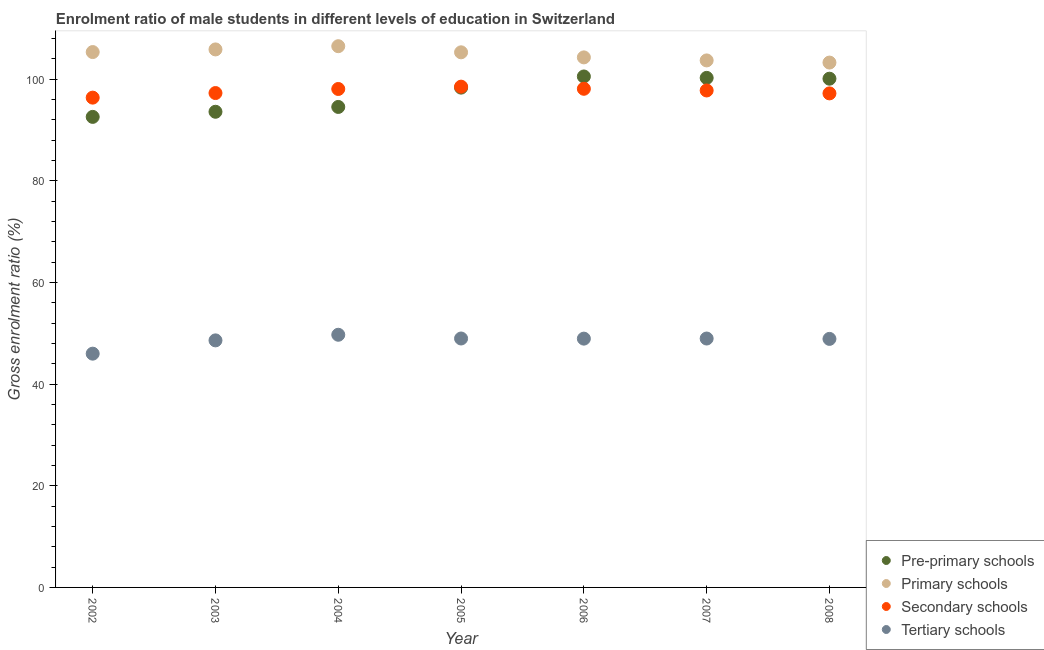How many different coloured dotlines are there?
Give a very brief answer. 4. What is the gross enrolment ratio(female) in primary schools in 2005?
Provide a short and direct response. 105.25. Across all years, what is the maximum gross enrolment ratio(female) in tertiary schools?
Your answer should be compact. 49.7. Across all years, what is the minimum gross enrolment ratio(female) in pre-primary schools?
Your response must be concise. 92.55. In which year was the gross enrolment ratio(female) in primary schools minimum?
Keep it short and to the point. 2008. What is the total gross enrolment ratio(female) in secondary schools in the graph?
Provide a short and direct response. 683.11. What is the difference between the gross enrolment ratio(female) in primary schools in 2005 and that in 2006?
Make the answer very short. 1. What is the difference between the gross enrolment ratio(female) in pre-primary schools in 2008 and the gross enrolment ratio(female) in tertiary schools in 2005?
Give a very brief answer. 51.1. What is the average gross enrolment ratio(female) in pre-primary schools per year?
Offer a very short reply. 97.1. In the year 2007, what is the difference between the gross enrolment ratio(female) in secondary schools and gross enrolment ratio(female) in pre-primary schools?
Provide a short and direct response. -2.48. In how many years, is the gross enrolment ratio(female) in pre-primary schools greater than 84 %?
Give a very brief answer. 7. What is the ratio of the gross enrolment ratio(female) in pre-primary schools in 2002 to that in 2005?
Keep it short and to the point. 0.94. Is the gross enrolment ratio(female) in secondary schools in 2004 less than that in 2005?
Your answer should be compact. Yes. Is the difference between the gross enrolment ratio(female) in primary schools in 2002 and 2005 greater than the difference between the gross enrolment ratio(female) in tertiary schools in 2002 and 2005?
Your response must be concise. Yes. What is the difference between the highest and the second highest gross enrolment ratio(female) in primary schools?
Offer a very short reply. 0.63. What is the difference between the highest and the lowest gross enrolment ratio(female) in primary schools?
Your response must be concise. 3.22. In how many years, is the gross enrolment ratio(female) in secondary schools greater than the average gross enrolment ratio(female) in secondary schools taken over all years?
Provide a succinct answer. 4. Is the sum of the gross enrolment ratio(female) in secondary schools in 2002 and 2004 greater than the maximum gross enrolment ratio(female) in tertiary schools across all years?
Ensure brevity in your answer.  Yes. Does the gross enrolment ratio(female) in tertiary schools monotonically increase over the years?
Keep it short and to the point. No. Is the gross enrolment ratio(female) in pre-primary schools strictly greater than the gross enrolment ratio(female) in tertiary schools over the years?
Your response must be concise. Yes. Is the gross enrolment ratio(female) in primary schools strictly less than the gross enrolment ratio(female) in secondary schools over the years?
Provide a succinct answer. No. How many dotlines are there?
Keep it short and to the point. 4. How many legend labels are there?
Your answer should be compact. 4. What is the title of the graph?
Provide a short and direct response. Enrolment ratio of male students in different levels of education in Switzerland. Does "Permanent crop land" appear as one of the legend labels in the graph?
Your response must be concise. No. What is the label or title of the X-axis?
Keep it short and to the point. Year. What is the Gross enrolment ratio (%) in Pre-primary schools in 2002?
Provide a succinct answer. 92.55. What is the Gross enrolment ratio (%) of Primary schools in 2002?
Offer a very short reply. 105.3. What is the Gross enrolment ratio (%) of Secondary schools in 2002?
Provide a succinct answer. 96.34. What is the Gross enrolment ratio (%) in Tertiary schools in 2002?
Provide a short and direct response. 45.98. What is the Gross enrolment ratio (%) of Pre-primary schools in 2003?
Keep it short and to the point. 93.56. What is the Gross enrolment ratio (%) in Primary schools in 2003?
Give a very brief answer. 105.82. What is the Gross enrolment ratio (%) of Secondary schools in 2003?
Provide a succinct answer. 97.24. What is the Gross enrolment ratio (%) in Tertiary schools in 2003?
Provide a succinct answer. 48.59. What is the Gross enrolment ratio (%) of Pre-primary schools in 2004?
Ensure brevity in your answer.  94.51. What is the Gross enrolment ratio (%) of Primary schools in 2004?
Provide a succinct answer. 106.45. What is the Gross enrolment ratio (%) of Secondary schools in 2004?
Your response must be concise. 98.04. What is the Gross enrolment ratio (%) in Tertiary schools in 2004?
Offer a terse response. 49.7. What is the Gross enrolment ratio (%) of Pre-primary schools in 2005?
Your answer should be compact. 98.31. What is the Gross enrolment ratio (%) of Primary schools in 2005?
Provide a succinct answer. 105.25. What is the Gross enrolment ratio (%) in Secondary schools in 2005?
Provide a short and direct response. 98.5. What is the Gross enrolment ratio (%) of Tertiary schools in 2005?
Keep it short and to the point. 48.96. What is the Gross enrolment ratio (%) of Pre-primary schools in 2006?
Your answer should be compact. 100.5. What is the Gross enrolment ratio (%) of Primary schools in 2006?
Your response must be concise. 104.25. What is the Gross enrolment ratio (%) of Secondary schools in 2006?
Keep it short and to the point. 98.08. What is the Gross enrolment ratio (%) in Tertiary schools in 2006?
Keep it short and to the point. 48.94. What is the Gross enrolment ratio (%) in Pre-primary schools in 2007?
Give a very brief answer. 100.22. What is the Gross enrolment ratio (%) of Primary schools in 2007?
Offer a very short reply. 103.66. What is the Gross enrolment ratio (%) in Secondary schools in 2007?
Ensure brevity in your answer.  97.75. What is the Gross enrolment ratio (%) of Tertiary schools in 2007?
Make the answer very short. 48.96. What is the Gross enrolment ratio (%) of Pre-primary schools in 2008?
Your answer should be compact. 100.06. What is the Gross enrolment ratio (%) in Primary schools in 2008?
Provide a succinct answer. 103.23. What is the Gross enrolment ratio (%) of Secondary schools in 2008?
Provide a short and direct response. 97.17. What is the Gross enrolment ratio (%) of Tertiary schools in 2008?
Offer a very short reply. 48.88. Across all years, what is the maximum Gross enrolment ratio (%) in Pre-primary schools?
Provide a short and direct response. 100.5. Across all years, what is the maximum Gross enrolment ratio (%) of Primary schools?
Ensure brevity in your answer.  106.45. Across all years, what is the maximum Gross enrolment ratio (%) of Secondary schools?
Give a very brief answer. 98.5. Across all years, what is the maximum Gross enrolment ratio (%) of Tertiary schools?
Offer a terse response. 49.7. Across all years, what is the minimum Gross enrolment ratio (%) in Pre-primary schools?
Offer a very short reply. 92.55. Across all years, what is the minimum Gross enrolment ratio (%) in Primary schools?
Provide a succinct answer. 103.23. Across all years, what is the minimum Gross enrolment ratio (%) of Secondary schools?
Provide a short and direct response. 96.34. Across all years, what is the minimum Gross enrolment ratio (%) in Tertiary schools?
Make the answer very short. 45.98. What is the total Gross enrolment ratio (%) in Pre-primary schools in the graph?
Your answer should be compact. 679.71. What is the total Gross enrolment ratio (%) in Primary schools in the graph?
Give a very brief answer. 733.98. What is the total Gross enrolment ratio (%) in Secondary schools in the graph?
Offer a very short reply. 683.11. What is the total Gross enrolment ratio (%) of Tertiary schools in the graph?
Make the answer very short. 340.01. What is the difference between the Gross enrolment ratio (%) in Pre-primary schools in 2002 and that in 2003?
Give a very brief answer. -1.01. What is the difference between the Gross enrolment ratio (%) of Primary schools in 2002 and that in 2003?
Your answer should be very brief. -0.52. What is the difference between the Gross enrolment ratio (%) of Secondary schools in 2002 and that in 2003?
Your response must be concise. -0.9. What is the difference between the Gross enrolment ratio (%) in Tertiary schools in 2002 and that in 2003?
Provide a succinct answer. -2.61. What is the difference between the Gross enrolment ratio (%) of Pre-primary schools in 2002 and that in 2004?
Ensure brevity in your answer.  -1.96. What is the difference between the Gross enrolment ratio (%) in Primary schools in 2002 and that in 2004?
Give a very brief answer. -1.15. What is the difference between the Gross enrolment ratio (%) of Secondary schools in 2002 and that in 2004?
Your response must be concise. -1.7. What is the difference between the Gross enrolment ratio (%) of Tertiary schools in 2002 and that in 2004?
Keep it short and to the point. -3.72. What is the difference between the Gross enrolment ratio (%) in Pre-primary schools in 2002 and that in 2005?
Offer a terse response. -5.76. What is the difference between the Gross enrolment ratio (%) in Primary schools in 2002 and that in 2005?
Your response must be concise. 0.05. What is the difference between the Gross enrolment ratio (%) in Secondary schools in 2002 and that in 2005?
Keep it short and to the point. -2.16. What is the difference between the Gross enrolment ratio (%) in Tertiary schools in 2002 and that in 2005?
Your response must be concise. -2.98. What is the difference between the Gross enrolment ratio (%) in Pre-primary schools in 2002 and that in 2006?
Give a very brief answer. -7.95. What is the difference between the Gross enrolment ratio (%) in Primary schools in 2002 and that in 2006?
Your response must be concise. 1.05. What is the difference between the Gross enrolment ratio (%) in Secondary schools in 2002 and that in 2006?
Your answer should be compact. -1.74. What is the difference between the Gross enrolment ratio (%) of Tertiary schools in 2002 and that in 2006?
Provide a short and direct response. -2.96. What is the difference between the Gross enrolment ratio (%) of Pre-primary schools in 2002 and that in 2007?
Make the answer very short. -7.67. What is the difference between the Gross enrolment ratio (%) of Primary schools in 2002 and that in 2007?
Provide a short and direct response. 1.64. What is the difference between the Gross enrolment ratio (%) in Secondary schools in 2002 and that in 2007?
Your response must be concise. -1.41. What is the difference between the Gross enrolment ratio (%) in Tertiary schools in 2002 and that in 2007?
Ensure brevity in your answer.  -2.98. What is the difference between the Gross enrolment ratio (%) in Pre-primary schools in 2002 and that in 2008?
Your answer should be compact. -7.51. What is the difference between the Gross enrolment ratio (%) of Primary schools in 2002 and that in 2008?
Keep it short and to the point. 2.07. What is the difference between the Gross enrolment ratio (%) in Secondary schools in 2002 and that in 2008?
Make the answer very short. -0.84. What is the difference between the Gross enrolment ratio (%) in Tertiary schools in 2002 and that in 2008?
Your answer should be compact. -2.91. What is the difference between the Gross enrolment ratio (%) in Pre-primary schools in 2003 and that in 2004?
Your answer should be compact. -0.95. What is the difference between the Gross enrolment ratio (%) of Primary schools in 2003 and that in 2004?
Offer a terse response. -0.63. What is the difference between the Gross enrolment ratio (%) in Secondary schools in 2003 and that in 2004?
Offer a terse response. -0.8. What is the difference between the Gross enrolment ratio (%) in Tertiary schools in 2003 and that in 2004?
Give a very brief answer. -1.1. What is the difference between the Gross enrolment ratio (%) in Pre-primary schools in 2003 and that in 2005?
Your response must be concise. -4.75. What is the difference between the Gross enrolment ratio (%) of Primary schools in 2003 and that in 2005?
Your response must be concise. 0.57. What is the difference between the Gross enrolment ratio (%) in Secondary schools in 2003 and that in 2005?
Your response must be concise. -1.26. What is the difference between the Gross enrolment ratio (%) of Tertiary schools in 2003 and that in 2005?
Keep it short and to the point. -0.37. What is the difference between the Gross enrolment ratio (%) of Pre-primary schools in 2003 and that in 2006?
Provide a short and direct response. -6.94. What is the difference between the Gross enrolment ratio (%) in Primary schools in 2003 and that in 2006?
Keep it short and to the point. 1.57. What is the difference between the Gross enrolment ratio (%) in Secondary schools in 2003 and that in 2006?
Keep it short and to the point. -0.84. What is the difference between the Gross enrolment ratio (%) in Tertiary schools in 2003 and that in 2006?
Your answer should be very brief. -0.34. What is the difference between the Gross enrolment ratio (%) of Pre-primary schools in 2003 and that in 2007?
Keep it short and to the point. -6.67. What is the difference between the Gross enrolment ratio (%) in Primary schools in 2003 and that in 2007?
Your answer should be very brief. 2.16. What is the difference between the Gross enrolment ratio (%) of Secondary schools in 2003 and that in 2007?
Provide a short and direct response. -0.51. What is the difference between the Gross enrolment ratio (%) of Tertiary schools in 2003 and that in 2007?
Keep it short and to the point. -0.36. What is the difference between the Gross enrolment ratio (%) of Pre-primary schools in 2003 and that in 2008?
Offer a terse response. -6.5. What is the difference between the Gross enrolment ratio (%) of Primary schools in 2003 and that in 2008?
Offer a very short reply. 2.59. What is the difference between the Gross enrolment ratio (%) of Secondary schools in 2003 and that in 2008?
Your answer should be compact. 0.07. What is the difference between the Gross enrolment ratio (%) in Tertiary schools in 2003 and that in 2008?
Your response must be concise. -0.29. What is the difference between the Gross enrolment ratio (%) in Pre-primary schools in 2004 and that in 2005?
Offer a very short reply. -3.8. What is the difference between the Gross enrolment ratio (%) of Primary schools in 2004 and that in 2005?
Provide a short and direct response. 1.2. What is the difference between the Gross enrolment ratio (%) of Secondary schools in 2004 and that in 2005?
Your response must be concise. -0.46. What is the difference between the Gross enrolment ratio (%) of Tertiary schools in 2004 and that in 2005?
Offer a terse response. 0.73. What is the difference between the Gross enrolment ratio (%) of Pre-primary schools in 2004 and that in 2006?
Your response must be concise. -5.99. What is the difference between the Gross enrolment ratio (%) of Primary schools in 2004 and that in 2006?
Make the answer very short. 2.2. What is the difference between the Gross enrolment ratio (%) of Secondary schools in 2004 and that in 2006?
Provide a succinct answer. -0.04. What is the difference between the Gross enrolment ratio (%) in Tertiary schools in 2004 and that in 2006?
Offer a very short reply. 0.76. What is the difference between the Gross enrolment ratio (%) in Pre-primary schools in 2004 and that in 2007?
Ensure brevity in your answer.  -5.72. What is the difference between the Gross enrolment ratio (%) in Primary schools in 2004 and that in 2007?
Provide a succinct answer. 2.8. What is the difference between the Gross enrolment ratio (%) of Secondary schools in 2004 and that in 2007?
Provide a succinct answer. 0.29. What is the difference between the Gross enrolment ratio (%) of Tertiary schools in 2004 and that in 2007?
Make the answer very short. 0.74. What is the difference between the Gross enrolment ratio (%) in Pre-primary schools in 2004 and that in 2008?
Your response must be concise. -5.56. What is the difference between the Gross enrolment ratio (%) in Primary schools in 2004 and that in 2008?
Keep it short and to the point. 3.22. What is the difference between the Gross enrolment ratio (%) in Secondary schools in 2004 and that in 2008?
Your answer should be compact. 0.87. What is the difference between the Gross enrolment ratio (%) in Tertiary schools in 2004 and that in 2008?
Make the answer very short. 0.81. What is the difference between the Gross enrolment ratio (%) in Pre-primary schools in 2005 and that in 2006?
Provide a short and direct response. -2.19. What is the difference between the Gross enrolment ratio (%) of Secondary schools in 2005 and that in 2006?
Keep it short and to the point. 0.42. What is the difference between the Gross enrolment ratio (%) of Tertiary schools in 2005 and that in 2006?
Your response must be concise. 0.03. What is the difference between the Gross enrolment ratio (%) of Pre-primary schools in 2005 and that in 2007?
Your response must be concise. -1.92. What is the difference between the Gross enrolment ratio (%) in Primary schools in 2005 and that in 2007?
Your answer should be compact. 1.59. What is the difference between the Gross enrolment ratio (%) of Secondary schools in 2005 and that in 2007?
Your answer should be very brief. 0.75. What is the difference between the Gross enrolment ratio (%) of Tertiary schools in 2005 and that in 2007?
Give a very brief answer. 0.01. What is the difference between the Gross enrolment ratio (%) in Pre-primary schools in 2005 and that in 2008?
Ensure brevity in your answer.  -1.76. What is the difference between the Gross enrolment ratio (%) in Primary schools in 2005 and that in 2008?
Keep it short and to the point. 2.02. What is the difference between the Gross enrolment ratio (%) in Secondary schools in 2005 and that in 2008?
Your answer should be compact. 1.33. What is the difference between the Gross enrolment ratio (%) of Tertiary schools in 2005 and that in 2008?
Offer a terse response. 0.08. What is the difference between the Gross enrolment ratio (%) in Pre-primary schools in 2006 and that in 2007?
Provide a succinct answer. 0.28. What is the difference between the Gross enrolment ratio (%) in Primary schools in 2006 and that in 2007?
Keep it short and to the point. 0.6. What is the difference between the Gross enrolment ratio (%) of Secondary schools in 2006 and that in 2007?
Provide a succinct answer. 0.33. What is the difference between the Gross enrolment ratio (%) in Tertiary schools in 2006 and that in 2007?
Make the answer very short. -0.02. What is the difference between the Gross enrolment ratio (%) of Pre-primary schools in 2006 and that in 2008?
Your answer should be compact. 0.44. What is the difference between the Gross enrolment ratio (%) of Primary schools in 2006 and that in 2008?
Offer a terse response. 1.02. What is the difference between the Gross enrolment ratio (%) in Secondary schools in 2006 and that in 2008?
Provide a succinct answer. 0.91. What is the difference between the Gross enrolment ratio (%) of Tertiary schools in 2006 and that in 2008?
Ensure brevity in your answer.  0.05. What is the difference between the Gross enrolment ratio (%) of Pre-primary schools in 2007 and that in 2008?
Keep it short and to the point. 0.16. What is the difference between the Gross enrolment ratio (%) in Primary schools in 2007 and that in 2008?
Offer a terse response. 0.42. What is the difference between the Gross enrolment ratio (%) of Secondary schools in 2007 and that in 2008?
Make the answer very short. 0.57. What is the difference between the Gross enrolment ratio (%) of Tertiary schools in 2007 and that in 2008?
Your response must be concise. 0.07. What is the difference between the Gross enrolment ratio (%) in Pre-primary schools in 2002 and the Gross enrolment ratio (%) in Primary schools in 2003?
Your answer should be very brief. -13.27. What is the difference between the Gross enrolment ratio (%) of Pre-primary schools in 2002 and the Gross enrolment ratio (%) of Secondary schools in 2003?
Your answer should be compact. -4.69. What is the difference between the Gross enrolment ratio (%) in Pre-primary schools in 2002 and the Gross enrolment ratio (%) in Tertiary schools in 2003?
Provide a succinct answer. 43.96. What is the difference between the Gross enrolment ratio (%) of Primary schools in 2002 and the Gross enrolment ratio (%) of Secondary schools in 2003?
Offer a terse response. 8.06. What is the difference between the Gross enrolment ratio (%) in Primary schools in 2002 and the Gross enrolment ratio (%) in Tertiary schools in 2003?
Provide a short and direct response. 56.71. What is the difference between the Gross enrolment ratio (%) in Secondary schools in 2002 and the Gross enrolment ratio (%) in Tertiary schools in 2003?
Give a very brief answer. 47.74. What is the difference between the Gross enrolment ratio (%) of Pre-primary schools in 2002 and the Gross enrolment ratio (%) of Primary schools in 2004?
Ensure brevity in your answer.  -13.9. What is the difference between the Gross enrolment ratio (%) in Pre-primary schools in 2002 and the Gross enrolment ratio (%) in Secondary schools in 2004?
Provide a succinct answer. -5.49. What is the difference between the Gross enrolment ratio (%) of Pre-primary schools in 2002 and the Gross enrolment ratio (%) of Tertiary schools in 2004?
Ensure brevity in your answer.  42.85. What is the difference between the Gross enrolment ratio (%) in Primary schools in 2002 and the Gross enrolment ratio (%) in Secondary schools in 2004?
Your response must be concise. 7.26. What is the difference between the Gross enrolment ratio (%) of Primary schools in 2002 and the Gross enrolment ratio (%) of Tertiary schools in 2004?
Your answer should be very brief. 55.6. What is the difference between the Gross enrolment ratio (%) in Secondary schools in 2002 and the Gross enrolment ratio (%) in Tertiary schools in 2004?
Ensure brevity in your answer.  46.64. What is the difference between the Gross enrolment ratio (%) in Pre-primary schools in 2002 and the Gross enrolment ratio (%) in Primary schools in 2005?
Provide a short and direct response. -12.7. What is the difference between the Gross enrolment ratio (%) of Pre-primary schools in 2002 and the Gross enrolment ratio (%) of Secondary schools in 2005?
Keep it short and to the point. -5.95. What is the difference between the Gross enrolment ratio (%) in Pre-primary schools in 2002 and the Gross enrolment ratio (%) in Tertiary schools in 2005?
Ensure brevity in your answer.  43.59. What is the difference between the Gross enrolment ratio (%) of Primary schools in 2002 and the Gross enrolment ratio (%) of Secondary schools in 2005?
Your answer should be compact. 6.8. What is the difference between the Gross enrolment ratio (%) of Primary schools in 2002 and the Gross enrolment ratio (%) of Tertiary schools in 2005?
Your answer should be very brief. 56.34. What is the difference between the Gross enrolment ratio (%) of Secondary schools in 2002 and the Gross enrolment ratio (%) of Tertiary schools in 2005?
Make the answer very short. 47.37. What is the difference between the Gross enrolment ratio (%) in Pre-primary schools in 2002 and the Gross enrolment ratio (%) in Primary schools in 2006?
Offer a very short reply. -11.7. What is the difference between the Gross enrolment ratio (%) of Pre-primary schools in 2002 and the Gross enrolment ratio (%) of Secondary schools in 2006?
Provide a short and direct response. -5.53. What is the difference between the Gross enrolment ratio (%) in Pre-primary schools in 2002 and the Gross enrolment ratio (%) in Tertiary schools in 2006?
Ensure brevity in your answer.  43.62. What is the difference between the Gross enrolment ratio (%) in Primary schools in 2002 and the Gross enrolment ratio (%) in Secondary schools in 2006?
Provide a short and direct response. 7.22. What is the difference between the Gross enrolment ratio (%) in Primary schools in 2002 and the Gross enrolment ratio (%) in Tertiary schools in 2006?
Give a very brief answer. 56.37. What is the difference between the Gross enrolment ratio (%) of Secondary schools in 2002 and the Gross enrolment ratio (%) of Tertiary schools in 2006?
Make the answer very short. 47.4. What is the difference between the Gross enrolment ratio (%) in Pre-primary schools in 2002 and the Gross enrolment ratio (%) in Primary schools in 2007?
Your answer should be compact. -11.11. What is the difference between the Gross enrolment ratio (%) in Pre-primary schools in 2002 and the Gross enrolment ratio (%) in Secondary schools in 2007?
Make the answer very short. -5.2. What is the difference between the Gross enrolment ratio (%) of Pre-primary schools in 2002 and the Gross enrolment ratio (%) of Tertiary schools in 2007?
Your answer should be compact. 43.59. What is the difference between the Gross enrolment ratio (%) of Primary schools in 2002 and the Gross enrolment ratio (%) of Secondary schools in 2007?
Offer a very short reply. 7.56. What is the difference between the Gross enrolment ratio (%) of Primary schools in 2002 and the Gross enrolment ratio (%) of Tertiary schools in 2007?
Keep it short and to the point. 56.35. What is the difference between the Gross enrolment ratio (%) in Secondary schools in 2002 and the Gross enrolment ratio (%) in Tertiary schools in 2007?
Offer a very short reply. 47.38. What is the difference between the Gross enrolment ratio (%) of Pre-primary schools in 2002 and the Gross enrolment ratio (%) of Primary schools in 2008?
Offer a very short reply. -10.68. What is the difference between the Gross enrolment ratio (%) in Pre-primary schools in 2002 and the Gross enrolment ratio (%) in Secondary schools in 2008?
Make the answer very short. -4.62. What is the difference between the Gross enrolment ratio (%) in Pre-primary schools in 2002 and the Gross enrolment ratio (%) in Tertiary schools in 2008?
Keep it short and to the point. 43.67. What is the difference between the Gross enrolment ratio (%) of Primary schools in 2002 and the Gross enrolment ratio (%) of Secondary schools in 2008?
Offer a very short reply. 8.13. What is the difference between the Gross enrolment ratio (%) of Primary schools in 2002 and the Gross enrolment ratio (%) of Tertiary schools in 2008?
Your response must be concise. 56.42. What is the difference between the Gross enrolment ratio (%) in Secondary schools in 2002 and the Gross enrolment ratio (%) in Tertiary schools in 2008?
Offer a very short reply. 47.45. What is the difference between the Gross enrolment ratio (%) in Pre-primary schools in 2003 and the Gross enrolment ratio (%) in Primary schools in 2004?
Provide a succinct answer. -12.9. What is the difference between the Gross enrolment ratio (%) of Pre-primary schools in 2003 and the Gross enrolment ratio (%) of Secondary schools in 2004?
Provide a succinct answer. -4.48. What is the difference between the Gross enrolment ratio (%) in Pre-primary schools in 2003 and the Gross enrolment ratio (%) in Tertiary schools in 2004?
Offer a terse response. 43.86. What is the difference between the Gross enrolment ratio (%) in Primary schools in 2003 and the Gross enrolment ratio (%) in Secondary schools in 2004?
Offer a very short reply. 7.78. What is the difference between the Gross enrolment ratio (%) in Primary schools in 2003 and the Gross enrolment ratio (%) in Tertiary schools in 2004?
Make the answer very short. 56.12. What is the difference between the Gross enrolment ratio (%) in Secondary schools in 2003 and the Gross enrolment ratio (%) in Tertiary schools in 2004?
Provide a short and direct response. 47.54. What is the difference between the Gross enrolment ratio (%) of Pre-primary schools in 2003 and the Gross enrolment ratio (%) of Primary schools in 2005?
Offer a terse response. -11.69. What is the difference between the Gross enrolment ratio (%) in Pre-primary schools in 2003 and the Gross enrolment ratio (%) in Secondary schools in 2005?
Give a very brief answer. -4.94. What is the difference between the Gross enrolment ratio (%) in Pre-primary schools in 2003 and the Gross enrolment ratio (%) in Tertiary schools in 2005?
Offer a terse response. 44.6. What is the difference between the Gross enrolment ratio (%) in Primary schools in 2003 and the Gross enrolment ratio (%) in Secondary schools in 2005?
Your answer should be very brief. 7.32. What is the difference between the Gross enrolment ratio (%) of Primary schools in 2003 and the Gross enrolment ratio (%) of Tertiary schools in 2005?
Provide a succinct answer. 56.86. What is the difference between the Gross enrolment ratio (%) in Secondary schools in 2003 and the Gross enrolment ratio (%) in Tertiary schools in 2005?
Provide a succinct answer. 48.28. What is the difference between the Gross enrolment ratio (%) in Pre-primary schools in 2003 and the Gross enrolment ratio (%) in Primary schools in 2006?
Your response must be concise. -10.7. What is the difference between the Gross enrolment ratio (%) in Pre-primary schools in 2003 and the Gross enrolment ratio (%) in Secondary schools in 2006?
Provide a succinct answer. -4.52. What is the difference between the Gross enrolment ratio (%) in Pre-primary schools in 2003 and the Gross enrolment ratio (%) in Tertiary schools in 2006?
Your answer should be very brief. 44.62. What is the difference between the Gross enrolment ratio (%) in Primary schools in 2003 and the Gross enrolment ratio (%) in Secondary schools in 2006?
Provide a succinct answer. 7.74. What is the difference between the Gross enrolment ratio (%) in Primary schools in 2003 and the Gross enrolment ratio (%) in Tertiary schools in 2006?
Make the answer very short. 56.89. What is the difference between the Gross enrolment ratio (%) of Secondary schools in 2003 and the Gross enrolment ratio (%) of Tertiary schools in 2006?
Make the answer very short. 48.3. What is the difference between the Gross enrolment ratio (%) of Pre-primary schools in 2003 and the Gross enrolment ratio (%) of Primary schools in 2007?
Your answer should be very brief. -10.1. What is the difference between the Gross enrolment ratio (%) in Pre-primary schools in 2003 and the Gross enrolment ratio (%) in Secondary schools in 2007?
Provide a short and direct response. -4.19. What is the difference between the Gross enrolment ratio (%) of Pre-primary schools in 2003 and the Gross enrolment ratio (%) of Tertiary schools in 2007?
Keep it short and to the point. 44.6. What is the difference between the Gross enrolment ratio (%) of Primary schools in 2003 and the Gross enrolment ratio (%) of Secondary schools in 2007?
Ensure brevity in your answer.  8.07. What is the difference between the Gross enrolment ratio (%) in Primary schools in 2003 and the Gross enrolment ratio (%) in Tertiary schools in 2007?
Keep it short and to the point. 56.86. What is the difference between the Gross enrolment ratio (%) in Secondary schools in 2003 and the Gross enrolment ratio (%) in Tertiary schools in 2007?
Your answer should be very brief. 48.28. What is the difference between the Gross enrolment ratio (%) in Pre-primary schools in 2003 and the Gross enrolment ratio (%) in Primary schools in 2008?
Keep it short and to the point. -9.68. What is the difference between the Gross enrolment ratio (%) of Pre-primary schools in 2003 and the Gross enrolment ratio (%) of Secondary schools in 2008?
Your answer should be very brief. -3.61. What is the difference between the Gross enrolment ratio (%) in Pre-primary schools in 2003 and the Gross enrolment ratio (%) in Tertiary schools in 2008?
Make the answer very short. 44.67. What is the difference between the Gross enrolment ratio (%) in Primary schools in 2003 and the Gross enrolment ratio (%) in Secondary schools in 2008?
Give a very brief answer. 8.65. What is the difference between the Gross enrolment ratio (%) of Primary schools in 2003 and the Gross enrolment ratio (%) of Tertiary schools in 2008?
Provide a short and direct response. 56.94. What is the difference between the Gross enrolment ratio (%) of Secondary schools in 2003 and the Gross enrolment ratio (%) of Tertiary schools in 2008?
Offer a terse response. 48.36. What is the difference between the Gross enrolment ratio (%) of Pre-primary schools in 2004 and the Gross enrolment ratio (%) of Primary schools in 2005?
Ensure brevity in your answer.  -10.74. What is the difference between the Gross enrolment ratio (%) in Pre-primary schools in 2004 and the Gross enrolment ratio (%) in Secondary schools in 2005?
Your answer should be very brief. -3.99. What is the difference between the Gross enrolment ratio (%) of Pre-primary schools in 2004 and the Gross enrolment ratio (%) of Tertiary schools in 2005?
Offer a terse response. 45.55. What is the difference between the Gross enrolment ratio (%) of Primary schools in 2004 and the Gross enrolment ratio (%) of Secondary schools in 2005?
Your response must be concise. 7.96. What is the difference between the Gross enrolment ratio (%) in Primary schools in 2004 and the Gross enrolment ratio (%) in Tertiary schools in 2005?
Provide a succinct answer. 57.49. What is the difference between the Gross enrolment ratio (%) in Secondary schools in 2004 and the Gross enrolment ratio (%) in Tertiary schools in 2005?
Give a very brief answer. 49.08. What is the difference between the Gross enrolment ratio (%) of Pre-primary schools in 2004 and the Gross enrolment ratio (%) of Primary schools in 2006?
Keep it short and to the point. -9.75. What is the difference between the Gross enrolment ratio (%) of Pre-primary schools in 2004 and the Gross enrolment ratio (%) of Secondary schools in 2006?
Keep it short and to the point. -3.57. What is the difference between the Gross enrolment ratio (%) in Pre-primary schools in 2004 and the Gross enrolment ratio (%) in Tertiary schools in 2006?
Provide a short and direct response. 45.57. What is the difference between the Gross enrolment ratio (%) of Primary schools in 2004 and the Gross enrolment ratio (%) of Secondary schools in 2006?
Ensure brevity in your answer.  8.38. What is the difference between the Gross enrolment ratio (%) in Primary schools in 2004 and the Gross enrolment ratio (%) in Tertiary schools in 2006?
Your response must be concise. 57.52. What is the difference between the Gross enrolment ratio (%) in Secondary schools in 2004 and the Gross enrolment ratio (%) in Tertiary schools in 2006?
Give a very brief answer. 49.1. What is the difference between the Gross enrolment ratio (%) of Pre-primary schools in 2004 and the Gross enrolment ratio (%) of Primary schools in 2007?
Your response must be concise. -9.15. What is the difference between the Gross enrolment ratio (%) in Pre-primary schools in 2004 and the Gross enrolment ratio (%) in Secondary schools in 2007?
Your response must be concise. -3.24. What is the difference between the Gross enrolment ratio (%) of Pre-primary schools in 2004 and the Gross enrolment ratio (%) of Tertiary schools in 2007?
Offer a terse response. 45.55. What is the difference between the Gross enrolment ratio (%) in Primary schools in 2004 and the Gross enrolment ratio (%) in Secondary schools in 2007?
Provide a succinct answer. 8.71. What is the difference between the Gross enrolment ratio (%) in Primary schools in 2004 and the Gross enrolment ratio (%) in Tertiary schools in 2007?
Your answer should be compact. 57.5. What is the difference between the Gross enrolment ratio (%) of Secondary schools in 2004 and the Gross enrolment ratio (%) of Tertiary schools in 2007?
Keep it short and to the point. 49.08. What is the difference between the Gross enrolment ratio (%) in Pre-primary schools in 2004 and the Gross enrolment ratio (%) in Primary schools in 2008?
Offer a very short reply. -8.73. What is the difference between the Gross enrolment ratio (%) of Pre-primary schools in 2004 and the Gross enrolment ratio (%) of Secondary schools in 2008?
Keep it short and to the point. -2.67. What is the difference between the Gross enrolment ratio (%) in Pre-primary schools in 2004 and the Gross enrolment ratio (%) in Tertiary schools in 2008?
Make the answer very short. 45.62. What is the difference between the Gross enrolment ratio (%) of Primary schools in 2004 and the Gross enrolment ratio (%) of Secondary schools in 2008?
Your response must be concise. 9.28. What is the difference between the Gross enrolment ratio (%) of Primary schools in 2004 and the Gross enrolment ratio (%) of Tertiary schools in 2008?
Offer a terse response. 57.57. What is the difference between the Gross enrolment ratio (%) in Secondary schools in 2004 and the Gross enrolment ratio (%) in Tertiary schools in 2008?
Provide a short and direct response. 49.16. What is the difference between the Gross enrolment ratio (%) in Pre-primary schools in 2005 and the Gross enrolment ratio (%) in Primary schools in 2006?
Your response must be concise. -5.95. What is the difference between the Gross enrolment ratio (%) in Pre-primary schools in 2005 and the Gross enrolment ratio (%) in Secondary schools in 2006?
Ensure brevity in your answer.  0.23. What is the difference between the Gross enrolment ratio (%) of Pre-primary schools in 2005 and the Gross enrolment ratio (%) of Tertiary schools in 2006?
Your answer should be very brief. 49.37. What is the difference between the Gross enrolment ratio (%) of Primary schools in 2005 and the Gross enrolment ratio (%) of Secondary schools in 2006?
Provide a short and direct response. 7.17. What is the difference between the Gross enrolment ratio (%) of Primary schools in 2005 and the Gross enrolment ratio (%) of Tertiary schools in 2006?
Keep it short and to the point. 56.32. What is the difference between the Gross enrolment ratio (%) of Secondary schools in 2005 and the Gross enrolment ratio (%) of Tertiary schools in 2006?
Your answer should be very brief. 49.56. What is the difference between the Gross enrolment ratio (%) of Pre-primary schools in 2005 and the Gross enrolment ratio (%) of Primary schools in 2007?
Give a very brief answer. -5.35. What is the difference between the Gross enrolment ratio (%) of Pre-primary schools in 2005 and the Gross enrolment ratio (%) of Secondary schools in 2007?
Ensure brevity in your answer.  0.56. What is the difference between the Gross enrolment ratio (%) of Pre-primary schools in 2005 and the Gross enrolment ratio (%) of Tertiary schools in 2007?
Your answer should be compact. 49.35. What is the difference between the Gross enrolment ratio (%) in Primary schools in 2005 and the Gross enrolment ratio (%) in Secondary schools in 2007?
Offer a terse response. 7.51. What is the difference between the Gross enrolment ratio (%) in Primary schools in 2005 and the Gross enrolment ratio (%) in Tertiary schools in 2007?
Keep it short and to the point. 56.3. What is the difference between the Gross enrolment ratio (%) in Secondary schools in 2005 and the Gross enrolment ratio (%) in Tertiary schools in 2007?
Offer a very short reply. 49.54. What is the difference between the Gross enrolment ratio (%) in Pre-primary schools in 2005 and the Gross enrolment ratio (%) in Primary schools in 2008?
Provide a succinct answer. -4.93. What is the difference between the Gross enrolment ratio (%) in Pre-primary schools in 2005 and the Gross enrolment ratio (%) in Secondary schools in 2008?
Give a very brief answer. 1.13. What is the difference between the Gross enrolment ratio (%) in Pre-primary schools in 2005 and the Gross enrolment ratio (%) in Tertiary schools in 2008?
Your response must be concise. 49.42. What is the difference between the Gross enrolment ratio (%) in Primary schools in 2005 and the Gross enrolment ratio (%) in Secondary schools in 2008?
Offer a very short reply. 8.08. What is the difference between the Gross enrolment ratio (%) in Primary schools in 2005 and the Gross enrolment ratio (%) in Tertiary schools in 2008?
Give a very brief answer. 56.37. What is the difference between the Gross enrolment ratio (%) of Secondary schools in 2005 and the Gross enrolment ratio (%) of Tertiary schools in 2008?
Your response must be concise. 49.61. What is the difference between the Gross enrolment ratio (%) of Pre-primary schools in 2006 and the Gross enrolment ratio (%) of Primary schools in 2007?
Keep it short and to the point. -3.16. What is the difference between the Gross enrolment ratio (%) in Pre-primary schools in 2006 and the Gross enrolment ratio (%) in Secondary schools in 2007?
Offer a terse response. 2.75. What is the difference between the Gross enrolment ratio (%) in Pre-primary schools in 2006 and the Gross enrolment ratio (%) in Tertiary schools in 2007?
Offer a terse response. 51.54. What is the difference between the Gross enrolment ratio (%) of Primary schools in 2006 and the Gross enrolment ratio (%) of Secondary schools in 2007?
Ensure brevity in your answer.  6.51. What is the difference between the Gross enrolment ratio (%) of Primary schools in 2006 and the Gross enrolment ratio (%) of Tertiary schools in 2007?
Your answer should be compact. 55.3. What is the difference between the Gross enrolment ratio (%) of Secondary schools in 2006 and the Gross enrolment ratio (%) of Tertiary schools in 2007?
Offer a very short reply. 49.12. What is the difference between the Gross enrolment ratio (%) of Pre-primary schools in 2006 and the Gross enrolment ratio (%) of Primary schools in 2008?
Your answer should be very brief. -2.73. What is the difference between the Gross enrolment ratio (%) of Pre-primary schools in 2006 and the Gross enrolment ratio (%) of Secondary schools in 2008?
Offer a terse response. 3.33. What is the difference between the Gross enrolment ratio (%) of Pre-primary schools in 2006 and the Gross enrolment ratio (%) of Tertiary schools in 2008?
Give a very brief answer. 51.62. What is the difference between the Gross enrolment ratio (%) in Primary schools in 2006 and the Gross enrolment ratio (%) in Secondary schools in 2008?
Provide a short and direct response. 7.08. What is the difference between the Gross enrolment ratio (%) in Primary schools in 2006 and the Gross enrolment ratio (%) in Tertiary schools in 2008?
Give a very brief answer. 55.37. What is the difference between the Gross enrolment ratio (%) in Secondary schools in 2006 and the Gross enrolment ratio (%) in Tertiary schools in 2008?
Your answer should be very brief. 49.19. What is the difference between the Gross enrolment ratio (%) of Pre-primary schools in 2007 and the Gross enrolment ratio (%) of Primary schools in 2008?
Your answer should be compact. -3.01. What is the difference between the Gross enrolment ratio (%) of Pre-primary schools in 2007 and the Gross enrolment ratio (%) of Secondary schools in 2008?
Provide a succinct answer. 3.05. What is the difference between the Gross enrolment ratio (%) in Pre-primary schools in 2007 and the Gross enrolment ratio (%) in Tertiary schools in 2008?
Offer a very short reply. 51.34. What is the difference between the Gross enrolment ratio (%) of Primary schools in 2007 and the Gross enrolment ratio (%) of Secondary schools in 2008?
Offer a terse response. 6.48. What is the difference between the Gross enrolment ratio (%) in Primary schools in 2007 and the Gross enrolment ratio (%) in Tertiary schools in 2008?
Keep it short and to the point. 54.77. What is the difference between the Gross enrolment ratio (%) of Secondary schools in 2007 and the Gross enrolment ratio (%) of Tertiary schools in 2008?
Keep it short and to the point. 48.86. What is the average Gross enrolment ratio (%) in Pre-primary schools per year?
Your answer should be very brief. 97.1. What is the average Gross enrolment ratio (%) in Primary schools per year?
Your response must be concise. 104.85. What is the average Gross enrolment ratio (%) in Secondary schools per year?
Offer a very short reply. 97.59. What is the average Gross enrolment ratio (%) of Tertiary schools per year?
Make the answer very short. 48.57. In the year 2002, what is the difference between the Gross enrolment ratio (%) in Pre-primary schools and Gross enrolment ratio (%) in Primary schools?
Provide a short and direct response. -12.75. In the year 2002, what is the difference between the Gross enrolment ratio (%) in Pre-primary schools and Gross enrolment ratio (%) in Secondary schools?
Your answer should be compact. -3.79. In the year 2002, what is the difference between the Gross enrolment ratio (%) of Pre-primary schools and Gross enrolment ratio (%) of Tertiary schools?
Offer a very short reply. 46.57. In the year 2002, what is the difference between the Gross enrolment ratio (%) in Primary schools and Gross enrolment ratio (%) in Secondary schools?
Your answer should be compact. 8.96. In the year 2002, what is the difference between the Gross enrolment ratio (%) of Primary schools and Gross enrolment ratio (%) of Tertiary schools?
Offer a very short reply. 59.32. In the year 2002, what is the difference between the Gross enrolment ratio (%) in Secondary schools and Gross enrolment ratio (%) in Tertiary schools?
Your answer should be very brief. 50.36. In the year 2003, what is the difference between the Gross enrolment ratio (%) of Pre-primary schools and Gross enrolment ratio (%) of Primary schools?
Offer a terse response. -12.26. In the year 2003, what is the difference between the Gross enrolment ratio (%) of Pre-primary schools and Gross enrolment ratio (%) of Secondary schools?
Your answer should be compact. -3.68. In the year 2003, what is the difference between the Gross enrolment ratio (%) in Pre-primary schools and Gross enrolment ratio (%) in Tertiary schools?
Provide a succinct answer. 44.97. In the year 2003, what is the difference between the Gross enrolment ratio (%) of Primary schools and Gross enrolment ratio (%) of Secondary schools?
Keep it short and to the point. 8.58. In the year 2003, what is the difference between the Gross enrolment ratio (%) of Primary schools and Gross enrolment ratio (%) of Tertiary schools?
Your response must be concise. 57.23. In the year 2003, what is the difference between the Gross enrolment ratio (%) of Secondary schools and Gross enrolment ratio (%) of Tertiary schools?
Provide a short and direct response. 48.65. In the year 2004, what is the difference between the Gross enrolment ratio (%) of Pre-primary schools and Gross enrolment ratio (%) of Primary schools?
Give a very brief answer. -11.95. In the year 2004, what is the difference between the Gross enrolment ratio (%) in Pre-primary schools and Gross enrolment ratio (%) in Secondary schools?
Make the answer very short. -3.53. In the year 2004, what is the difference between the Gross enrolment ratio (%) of Pre-primary schools and Gross enrolment ratio (%) of Tertiary schools?
Keep it short and to the point. 44.81. In the year 2004, what is the difference between the Gross enrolment ratio (%) of Primary schools and Gross enrolment ratio (%) of Secondary schools?
Your response must be concise. 8.42. In the year 2004, what is the difference between the Gross enrolment ratio (%) in Primary schools and Gross enrolment ratio (%) in Tertiary schools?
Keep it short and to the point. 56.76. In the year 2004, what is the difference between the Gross enrolment ratio (%) in Secondary schools and Gross enrolment ratio (%) in Tertiary schools?
Provide a short and direct response. 48.34. In the year 2005, what is the difference between the Gross enrolment ratio (%) of Pre-primary schools and Gross enrolment ratio (%) of Primary schools?
Your answer should be very brief. -6.95. In the year 2005, what is the difference between the Gross enrolment ratio (%) of Pre-primary schools and Gross enrolment ratio (%) of Secondary schools?
Offer a terse response. -0.19. In the year 2005, what is the difference between the Gross enrolment ratio (%) in Pre-primary schools and Gross enrolment ratio (%) in Tertiary schools?
Offer a very short reply. 49.34. In the year 2005, what is the difference between the Gross enrolment ratio (%) in Primary schools and Gross enrolment ratio (%) in Secondary schools?
Your answer should be compact. 6.75. In the year 2005, what is the difference between the Gross enrolment ratio (%) in Primary schools and Gross enrolment ratio (%) in Tertiary schools?
Ensure brevity in your answer.  56.29. In the year 2005, what is the difference between the Gross enrolment ratio (%) in Secondary schools and Gross enrolment ratio (%) in Tertiary schools?
Your answer should be very brief. 49.54. In the year 2006, what is the difference between the Gross enrolment ratio (%) of Pre-primary schools and Gross enrolment ratio (%) of Primary schools?
Provide a succinct answer. -3.75. In the year 2006, what is the difference between the Gross enrolment ratio (%) in Pre-primary schools and Gross enrolment ratio (%) in Secondary schools?
Offer a very short reply. 2.42. In the year 2006, what is the difference between the Gross enrolment ratio (%) in Pre-primary schools and Gross enrolment ratio (%) in Tertiary schools?
Ensure brevity in your answer.  51.56. In the year 2006, what is the difference between the Gross enrolment ratio (%) in Primary schools and Gross enrolment ratio (%) in Secondary schools?
Keep it short and to the point. 6.18. In the year 2006, what is the difference between the Gross enrolment ratio (%) in Primary schools and Gross enrolment ratio (%) in Tertiary schools?
Offer a very short reply. 55.32. In the year 2006, what is the difference between the Gross enrolment ratio (%) of Secondary schools and Gross enrolment ratio (%) of Tertiary schools?
Make the answer very short. 49.14. In the year 2007, what is the difference between the Gross enrolment ratio (%) in Pre-primary schools and Gross enrolment ratio (%) in Primary schools?
Give a very brief answer. -3.43. In the year 2007, what is the difference between the Gross enrolment ratio (%) of Pre-primary schools and Gross enrolment ratio (%) of Secondary schools?
Give a very brief answer. 2.48. In the year 2007, what is the difference between the Gross enrolment ratio (%) of Pre-primary schools and Gross enrolment ratio (%) of Tertiary schools?
Offer a very short reply. 51.27. In the year 2007, what is the difference between the Gross enrolment ratio (%) of Primary schools and Gross enrolment ratio (%) of Secondary schools?
Ensure brevity in your answer.  5.91. In the year 2007, what is the difference between the Gross enrolment ratio (%) of Primary schools and Gross enrolment ratio (%) of Tertiary schools?
Offer a very short reply. 54.7. In the year 2007, what is the difference between the Gross enrolment ratio (%) in Secondary schools and Gross enrolment ratio (%) in Tertiary schools?
Provide a succinct answer. 48.79. In the year 2008, what is the difference between the Gross enrolment ratio (%) in Pre-primary schools and Gross enrolment ratio (%) in Primary schools?
Provide a succinct answer. -3.17. In the year 2008, what is the difference between the Gross enrolment ratio (%) in Pre-primary schools and Gross enrolment ratio (%) in Secondary schools?
Provide a succinct answer. 2.89. In the year 2008, what is the difference between the Gross enrolment ratio (%) of Pre-primary schools and Gross enrolment ratio (%) of Tertiary schools?
Give a very brief answer. 51.18. In the year 2008, what is the difference between the Gross enrolment ratio (%) in Primary schools and Gross enrolment ratio (%) in Secondary schools?
Ensure brevity in your answer.  6.06. In the year 2008, what is the difference between the Gross enrolment ratio (%) in Primary schools and Gross enrolment ratio (%) in Tertiary schools?
Offer a terse response. 54.35. In the year 2008, what is the difference between the Gross enrolment ratio (%) in Secondary schools and Gross enrolment ratio (%) in Tertiary schools?
Provide a short and direct response. 48.29. What is the ratio of the Gross enrolment ratio (%) of Secondary schools in 2002 to that in 2003?
Keep it short and to the point. 0.99. What is the ratio of the Gross enrolment ratio (%) of Tertiary schools in 2002 to that in 2003?
Provide a succinct answer. 0.95. What is the ratio of the Gross enrolment ratio (%) in Pre-primary schools in 2002 to that in 2004?
Make the answer very short. 0.98. What is the ratio of the Gross enrolment ratio (%) in Secondary schools in 2002 to that in 2004?
Your answer should be compact. 0.98. What is the ratio of the Gross enrolment ratio (%) in Tertiary schools in 2002 to that in 2004?
Give a very brief answer. 0.93. What is the ratio of the Gross enrolment ratio (%) of Pre-primary schools in 2002 to that in 2005?
Provide a succinct answer. 0.94. What is the ratio of the Gross enrolment ratio (%) of Secondary schools in 2002 to that in 2005?
Ensure brevity in your answer.  0.98. What is the ratio of the Gross enrolment ratio (%) of Tertiary schools in 2002 to that in 2005?
Your response must be concise. 0.94. What is the ratio of the Gross enrolment ratio (%) in Pre-primary schools in 2002 to that in 2006?
Provide a short and direct response. 0.92. What is the ratio of the Gross enrolment ratio (%) in Secondary schools in 2002 to that in 2006?
Offer a very short reply. 0.98. What is the ratio of the Gross enrolment ratio (%) of Tertiary schools in 2002 to that in 2006?
Your answer should be compact. 0.94. What is the ratio of the Gross enrolment ratio (%) in Pre-primary schools in 2002 to that in 2007?
Your answer should be very brief. 0.92. What is the ratio of the Gross enrolment ratio (%) in Primary schools in 2002 to that in 2007?
Offer a terse response. 1.02. What is the ratio of the Gross enrolment ratio (%) in Secondary schools in 2002 to that in 2007?
Provide a succinct answer. 0.99. What is the ratio of the Gross enrolment ratio (%) in Tertiary schools in 2002 to that in 2007?
Your answer should be compact. 0.94. What is the ratio of the Gross enrolment ratio (%) of Pre-primary schools in 2002 to that in 2008?
Provide a short and direct response. 0.92. What is the ratio of the Gross enrolment ratio (%) of Primary schools in 2002 to that in 2008?
Ensure brevity in your answer.  1.02. What is the ratio of the Gross enrolment ratio (%) in Tertiary schools in 2002 to that in 2008?
Your answer should be very brief. 0.94. What is the ratio of the Gross enrolment ratio (%) of Tertiary schools in 2003 to that in 2004?
Make the answer very short. 0.98. What is the ratio of the Gross enrolment ratio (%) in Pre-primary schools in 2003 to that in 2005?
Your answer should be compact. 0.95. What is the ratio of the Gross enrolment ratio (%) of Primary schools in 2003 to that in 2005?
Provide a short and direct response. 1.01. What is the ratio of the Gross enrolment ratio (%) of Secondary schools in 2003 to that in 2005?
Keep it short and to the point. 0.99. What is the ratio of the Gross enrolment ratio (%) of Pre-primary schools in 2003 to that in 2006?
Your response must be concise. 0.93. What is the ratio of the Gross enrolment ratio (%) of Secondary schools in 2003 to that in 2006?
Your answer should be compact. 0.99. What is the ratio of the Gross enrolment ratio (%) of Tertiary schools in 2003 to that in 2006?
Your answer should be very brief. 0.99. What is the ratio of the Gross enrolment ratio (%) in Pre-primary schools in 2003 to that in 2007?
Your response must be concise. 0.93. What is the ratio of the Gross enrolment ratio (%) in Primary schools in 2003 to that in 2007?
Give a very brief answer. 1.02. What is the ratio of the Gross enrolment ratio (%) in Secondary schools in 2003 to that in 2007?
Provide a succinct answer. 0.99. What is the ratio of the Gross enrolment ratio (%) in Pre-primary schools in 2003 to that in 2008?
Your response must be concise. 0.94. What is the ratio of the Gross enrolment ratio (%) in Primary schools in 2003 to that in 2008?
Keep it short and to the point. 1.03. What is the ratio of the Gross enrolment ratio (%) of Tertiary schools in 2003 to that in 2008?
Your answer should be very brief. 0.99. What is the ratio of the Gross enrolment ratio (%) of Pre-primary schools in 2004 to that in 2005?
Your answer should be compact. 0.96. What is the ratio of the Gross enrolment ratio (%) in Primary schools in 2004 to that in 2005?
Your answer should be very brief. 1.01. What is the ratio of the Gross enrolment ratio (%) of Pre-primary schools in 2004 to that in 2006?
Keep it short and to the point. 0.94. What is the ratio of the Gross enrolment ratio (%) of Primary schools in 2004 to that in 2006?
Offer a terse response. 1.02. What is the ratio of the Gross enrolment ratio (%) of Secondary schools in 2004 to that in 2006?
Your response must be concise. 1. What is the ratio of the Gross enrolment ratio (%) in Tertiary schools in 2004 to that in 2006?
Ensure brevity in your answer.  1.02. What is the ratio of the Gross enrolment ratio (%) in Pre-primary schools in 2004 to that in 2007?
Give a very brief answer. 0.94. What is the ratio of the Gross enrolment ratio (%) in Secondary schools in 2004 to that in 2007?
Give a very brief answer. 1. What is the ratio of the Gross enrolment ratio (%) of Tertiary schools in 2004 to that in 2007?
Provide a short and direct response. 1.02. What is the ratio of the Gross enrolment ratio (%) of Pre-primary schools in 2004 to that in 2008?
Your answer should be compact. 0.94. What is the ratio of the Gross enrolment ratio (%) of Primary schools in 2004 to that in 2008?
Ensure brevity in your answer.  1.03. What is the ratio of the Gross enrolment ratio (%) of Secondary schools in 2004 to that in 2008?
Make the answer very short. 1.01. What is the ratio of the Gross enrolment ratio (%) of Tertiary schools in 2004 to that in 2008?
Offer a very short reply. 1.02. What is the ratio of the Gross enrolment ratio (%) in Pre-primary schools in 2005 to that in 2006?
Provide a short and direct response. 0.98. What is the ratio of the Gross enrolment ratio (%) in Primary schools in 2005 to that in 2006?
Offer a very short reply. 1.01. What is the ratio of the Gross enrolment ratio (%) of Secondary schools in 2005 to that in 2006?
Your answer should be compact. 1. What is the ratio of the Gross enrolment ratio (%) in Tertiary schools in 2005 to that in 2006?
Ensure brevity in your answer.  1. What is the ratio of the Gross enrolment ratio (%) of Pre-primary schools in 2005 to that in 2007?
Offer a terse response. 0.98. What is the ratio of the Gross enrolment ratio (%) of Primary schools in 2005 to that in 2007?
Your answer should be very brief. 1.02. What is the ratio of the Gross enrolment ratio (%) in Secondary schools in 2005 to that in 2007?
Ensure brevity in your answer.  1.01. What is the ratio of the Gross enrolment ratio (%) of Tertiary schools in 2005 to that in 2007?
Keep it short and to the point. 1. What is the ratio of the Gross enrolment ratio (%) in Pre-primary schools in 2005 to that in 2008?
Make the answer very short. 0.98. What is the ratio of the Gross enrolment ratio (%) in Primary schools in 2005 to that in 2008?
Provide a succinct answer. 1.02. What is the ratio of the Gross enrolment ratio (%) in Secondary schools in 2005 to that in 2008?
Offer a terse response. 1.01. What is the ratio of the Gross enrolment ratio (%) in Primary schools in 2006 to that in 2007?
Keep it short and to the point. 1.01. What is the ratio of the Gross enrolment ratio (%) in Secondary schools in 2006 to that in 2007?
Offer a very short reply. 1. What is the ratio of the Gross enrolment ratio (%) in Tertiary schools in 2006 to that in 2007?
Keep it short and to the point. 1. What is the ratio of the Gross enrolment ratio (%) of Primary schools in 2006 to that in 2008?
Provide a succinct answer. 1.01. What is the ratio of the Gross enrolment ratio (%) in Secondary schools in 2006 to that in 2008?
Offer a very short reply. 1.01. What is the ratio of the Gross enrolment ratio (%) in Tertiary schools in 2006 to that in 2008?
Provide a succinct answer. 1. What is the ratio of the Gross enrolment ratio (%) of Primary schools in 2007 to that in 2008?
Make the answer very short. 1. What is the ratio of the Gross enrolment ratio (%) of Secondary schools in 2007 to that in 2008?
Provide a succinct answer. 1.01. What is the ratio of the Gross enrolment ratio (%) of Tertiary schools in 2007 to that in 2008?
Ensure brevity in your answer.  1. What is the difference between the highest and the second highest Gross enrolment ratio (%) in Pre-primary schools?
Provide a succinct answer. 0.28. What is the difference between the highest and the second highest Gross enrolment ratio (%) of Primary schools?
Give a very brief answer. 0.63. What is the difference between the highest and the second highest Gross enrolment ratio (%) in Secondary schools?
Offer a terse response. 0.42. What is the difference between the highest and the second highest Gross enrolment ratio (%) in Tertiary schools?
Offer a terse response. 0.73. What is the difference between the highest and the lowest Gross enrolment ratio (%) in Pre-primary schools?
Provide a succinct answer. 7.95. What is the difference between the highest and the lowest Gross enrolment ratio (%) of Primary schools?
Offer a very short reply. 3.22. What is the difference between the highest and the lowest Gross enrolment ratio (%) of Secondary schools?
Give a very brief answer. 2.16. What is the difference between the highest and the lowest Gross enrolment ratio (%) of Tertiary schools?
Provide a succinct answer. 3.72. 